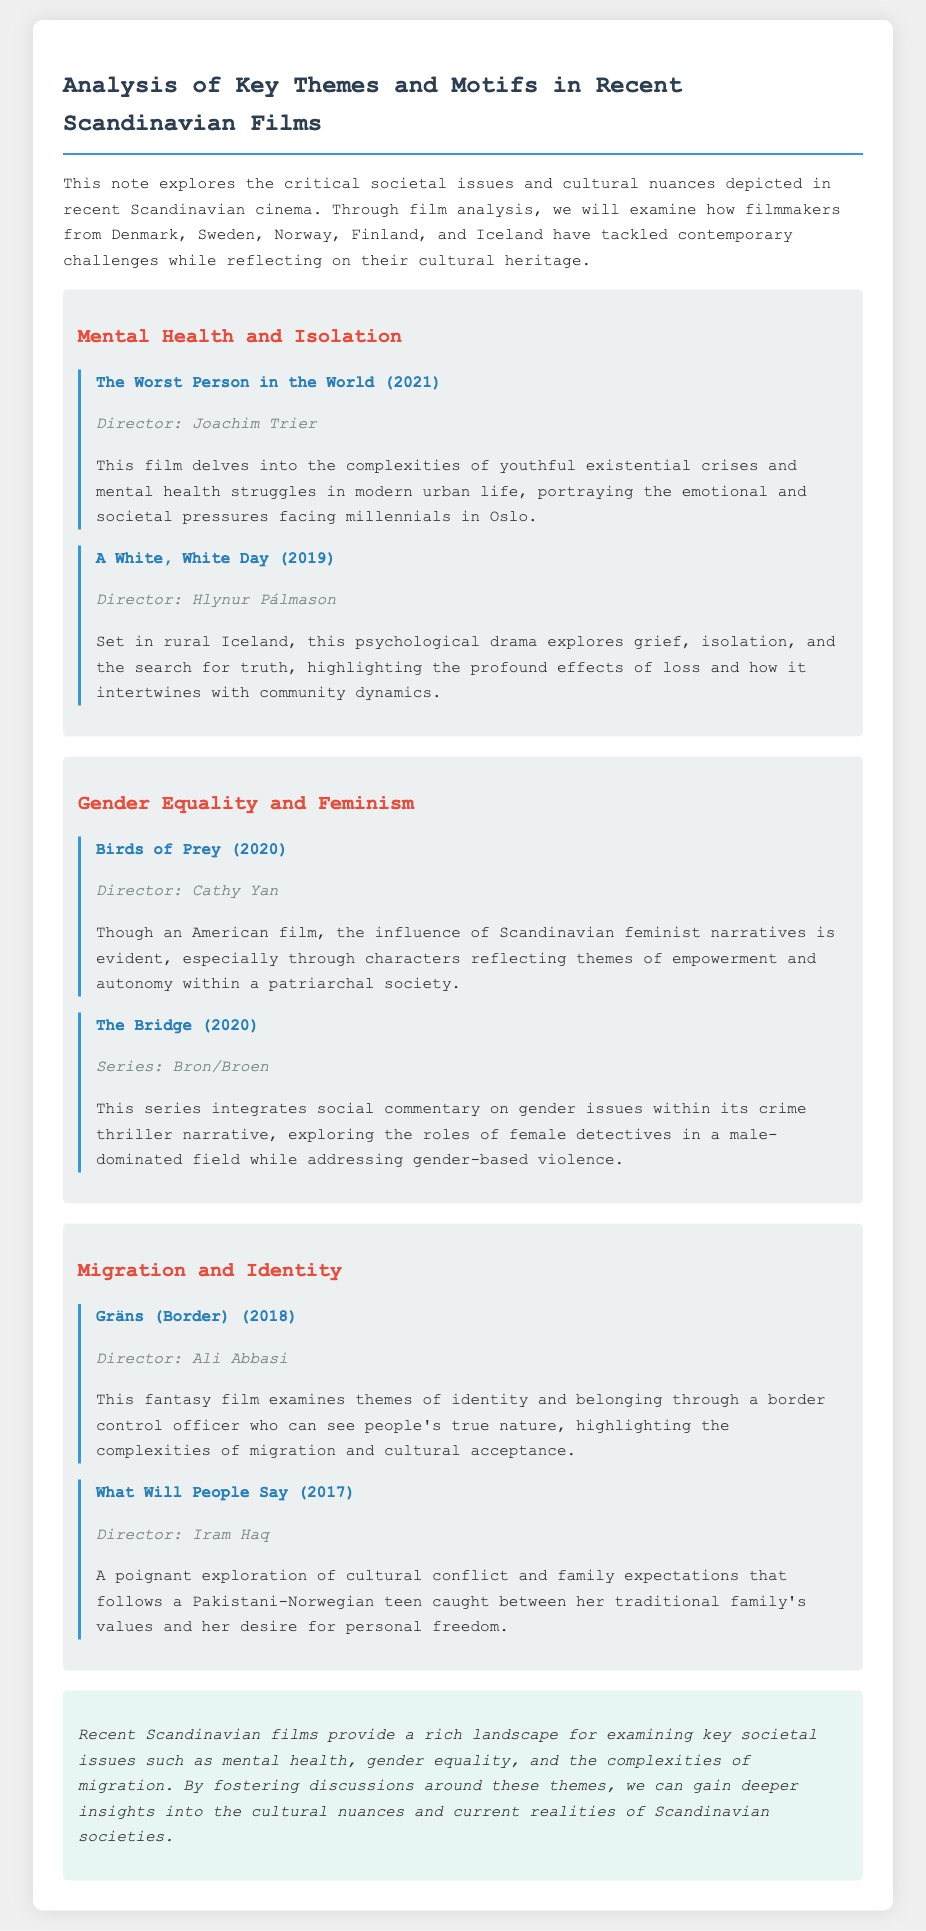What is the title of the film directed by Joachim Trier? The title of the film is mentioned in the first theme discussing mental health and isolation.
Answer: The Worst Person in the World Who directed "A White, White Day"? This information is provided in the description of the film discussing mental health and isolation.
Answer: Hlynur Pálmason What societal issue is explored in the film "Gräns (Border)"? This film is discussed under the migration and identity theme, highlighting the issue of belonging.
Answer: Identity Which series addresses gender issues within a crime thriller narrative? The relevant series is listed under the gender equality and feminism theme.
Answer: The Bridge What year was "What Will People Say" released? This information can be found in the migration and identity section of the document.
Answer: 2017 How many themes are discussed in the document? By counting the sections present in the note, we see that there are distinct themes listed.
Answer: Three What is the primary focus of recent Scandinavian films according to the conclusion? The conclusion summarizes the themes discussed throughout the document.
Answer: Societal issues What theme does the film "Birds of Prey" relate to? The reference to this film is under gender equality and feminism, linking it to the specific theme.
Answer: Gender Equality and Feminism 